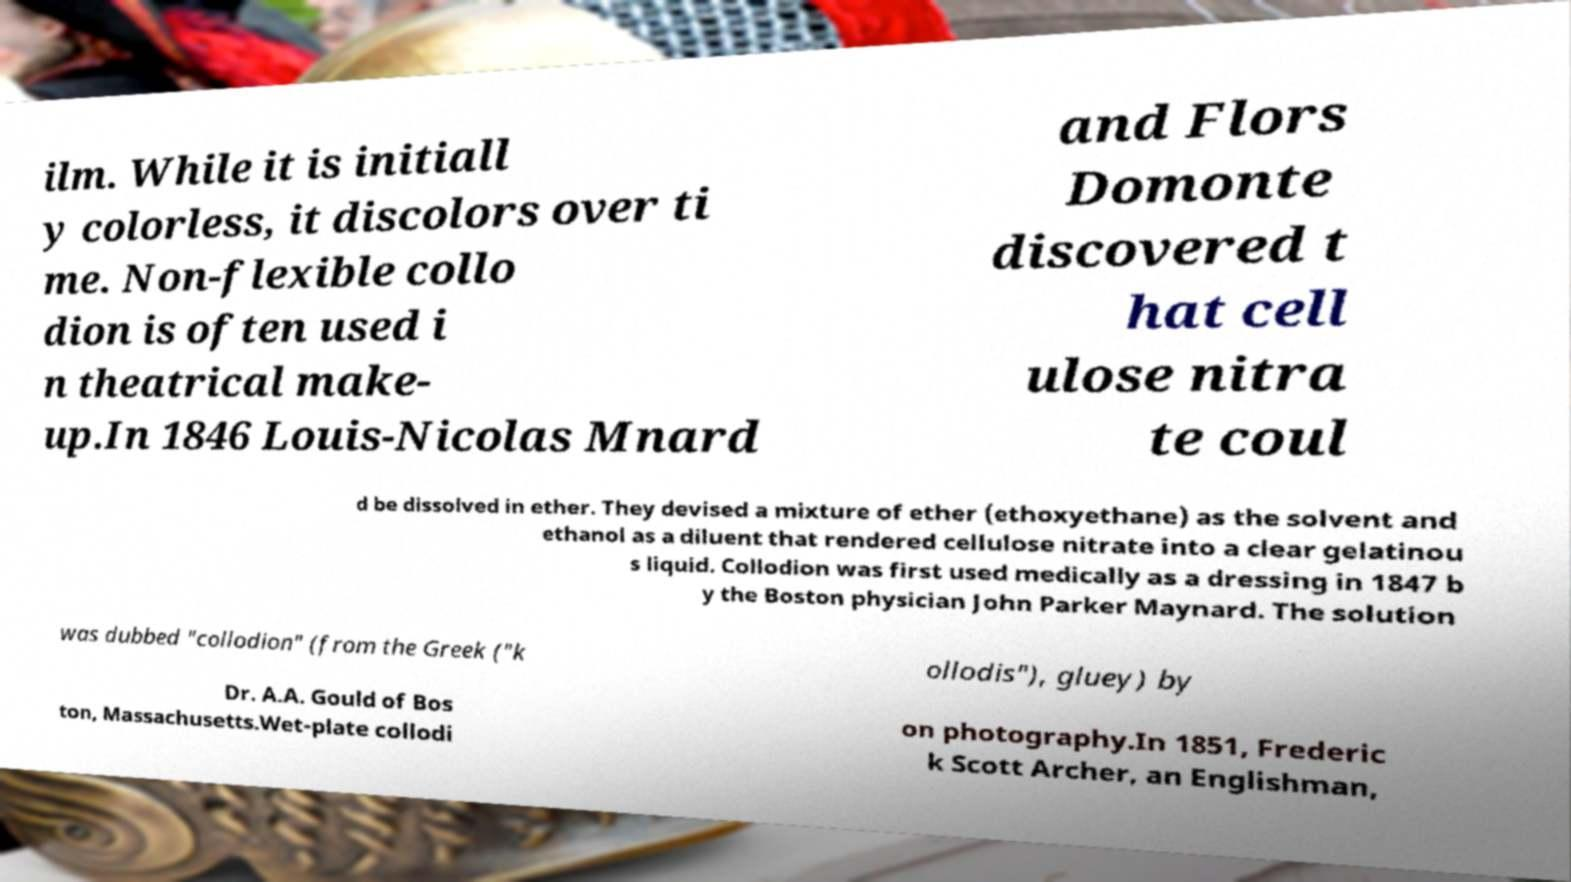Could you assist in decoding the text presented in this image and type it out clearly? ilm. While it is initiall y colorless, it discolors over ti me. Non-flexible collo dion is often used i n theatrical make- up.In 1846 Louis-Nicolas Mnard and Flors Domonte discovered t hat cell ulose nitra te coul d be dissolved in ether. They devised a mixture of ether (ethoxyethane) as the solvent and ethanol as a diluent that rendered cellulose nitrate into a clear gelatinou s liquid. Collodion was first used medically as a dressing in 1847 b y the Boston physician John Parker Maynard. The solution was dubbed "collodion" (from the Greek ("k ollodis"), gluey) by Dr. A.A. Gould of Bos ton, Massachusetts.Wet-plate collodi on photography.In 1851, Frederic k Scott Archer, an Englishman, 